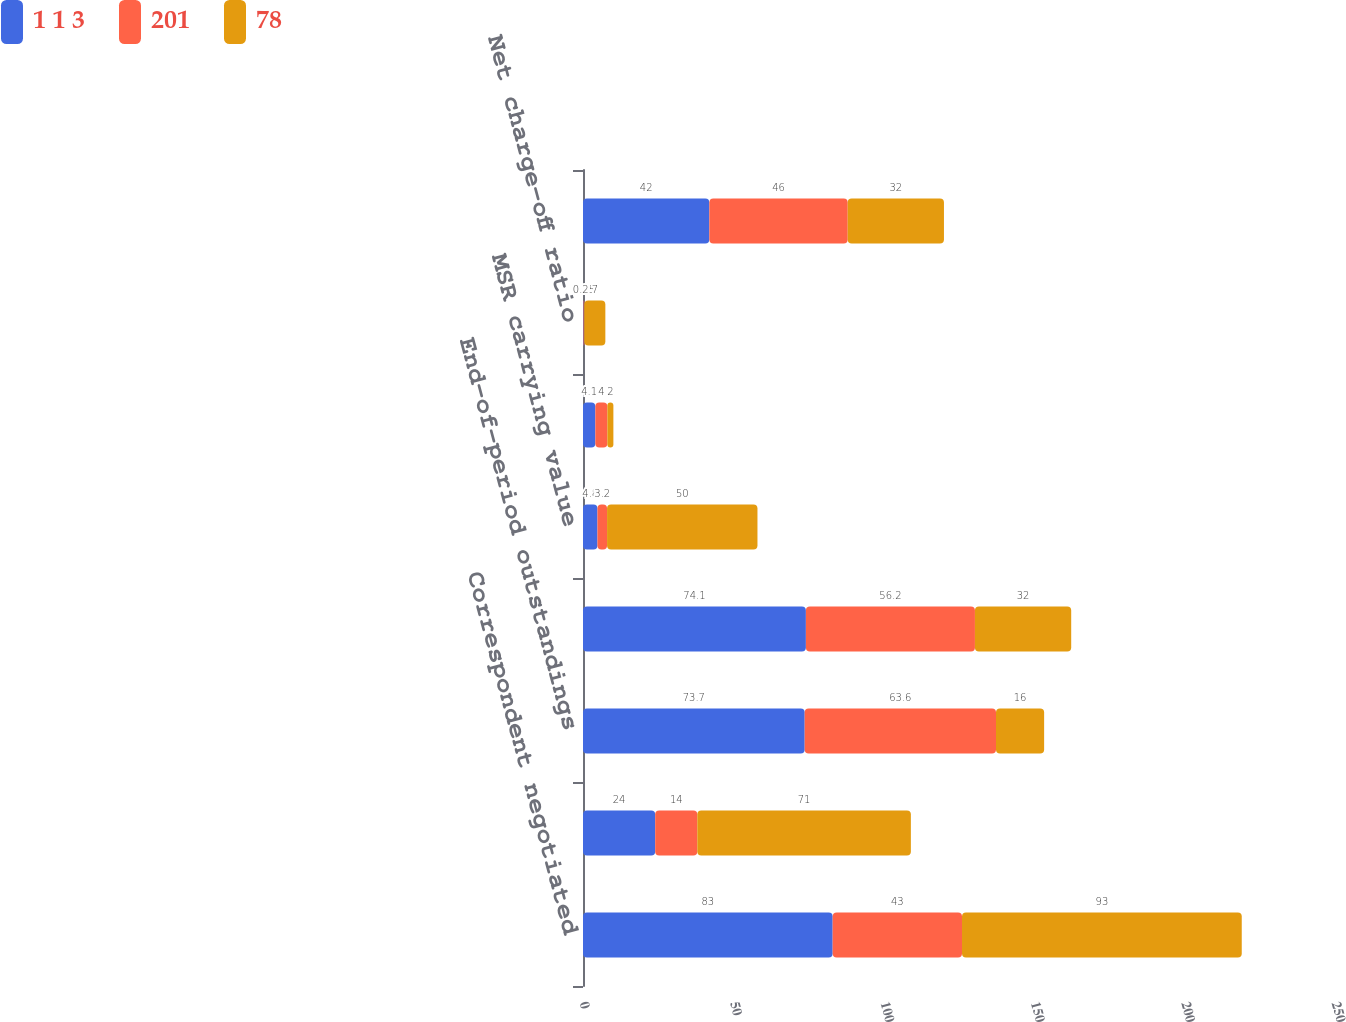Convert chart. <chart><loc_0><loc_0><loc_500><loc_500><stacked_bar_chart><ecel><fcel>Correspondent negotiated<fcel>Home equity<fcel>End-of-period outstandings<fcel>Total average loans owned<fcel>MSR carrying value<fcel>Number of customers (in<fcel>Net charge-off ratio<fcel>Overhead ratio<nl><fcel>1 1 3<fcel>83<fcel>24<fcel>73.7<fcel>74.1<fcel>4.8<fcel>4.1<fcel>0.18<fcel>42<nl><fcel>201<fcel>43<fcel>14<fcel>63.6<fcel>56.2<fcel>3.2<fcel>4<fcel>0.25<fcel>46<nl><fcel>78<fcel>93<fcel>71<fcel>16<fcel>32<fcel>50<fcel>2<fcel>7<fcel>32<nl></chart> 